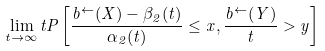Convert formula to latex. <formula><loc_0><loc_0><loc_500><loc_500>\lim _ { t \to \infty } t P \left [ \frac { b ^ { \leftarrow } ( X ) - \beta _ { 2 } ( t ) } { \alpha _ { 2 } ( t ) } \leq x , \frac { b ^ { \leftarrow } ( Y ) } { t } > y \right ]</formula> 